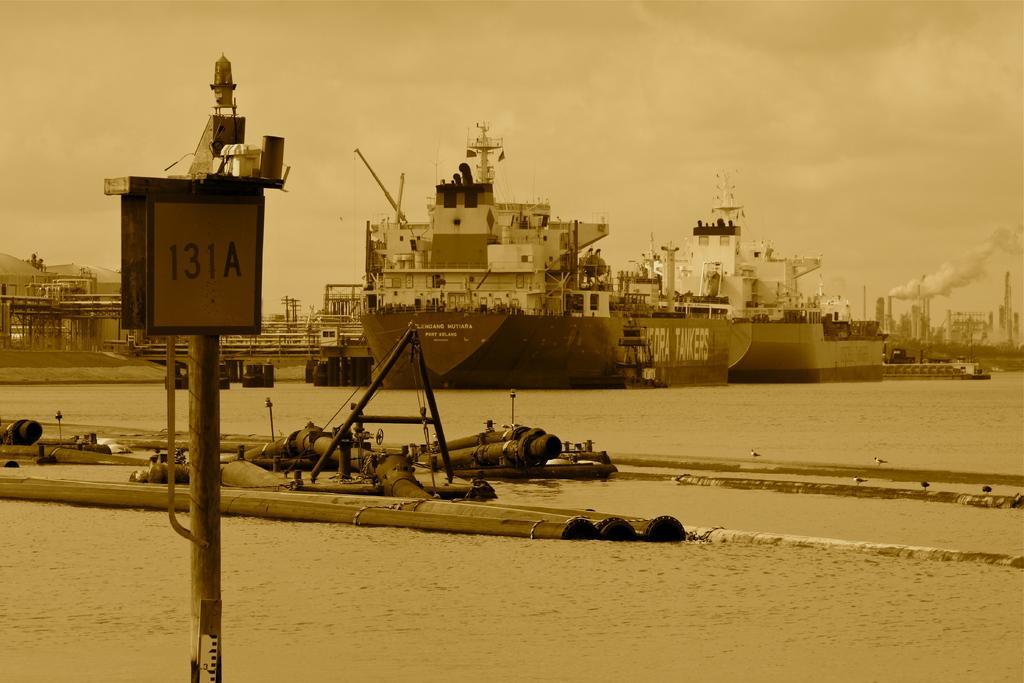Describe this image in one or two sentences. In this image I can see the water, few pipes on the surface of the water, a pole and a board to the pole and in the background I can see few ships, a bridge, few buildings, some smoke and the sky. 